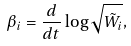<formula> <loc_0><loc_0><loc_500><loc_500>\beta _ { i } = \frac { d } { d t } \log \sqrt { \tilde { W } _ { i } } ,</formula> 